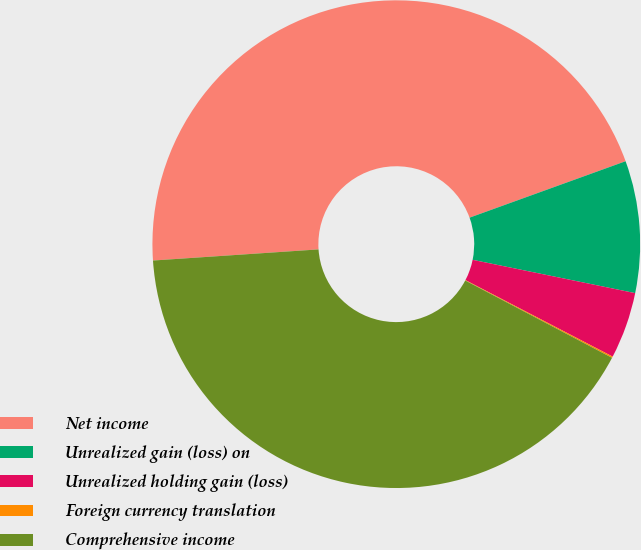<chart> <loc_0><loc_0><loc_500><loc_500><pie_chart><fcel>Net income<fcel>Unrealized gain (loss) on<fcel>Unrealized holding gain (loss)<fcel>Foreign currency translation<fcel>Comprehensive income<nl><fcel>45.54%<fcel>8.74%<fcel>4.41%<fcel>0.09%<fcel>41.21%<nl></chart> 